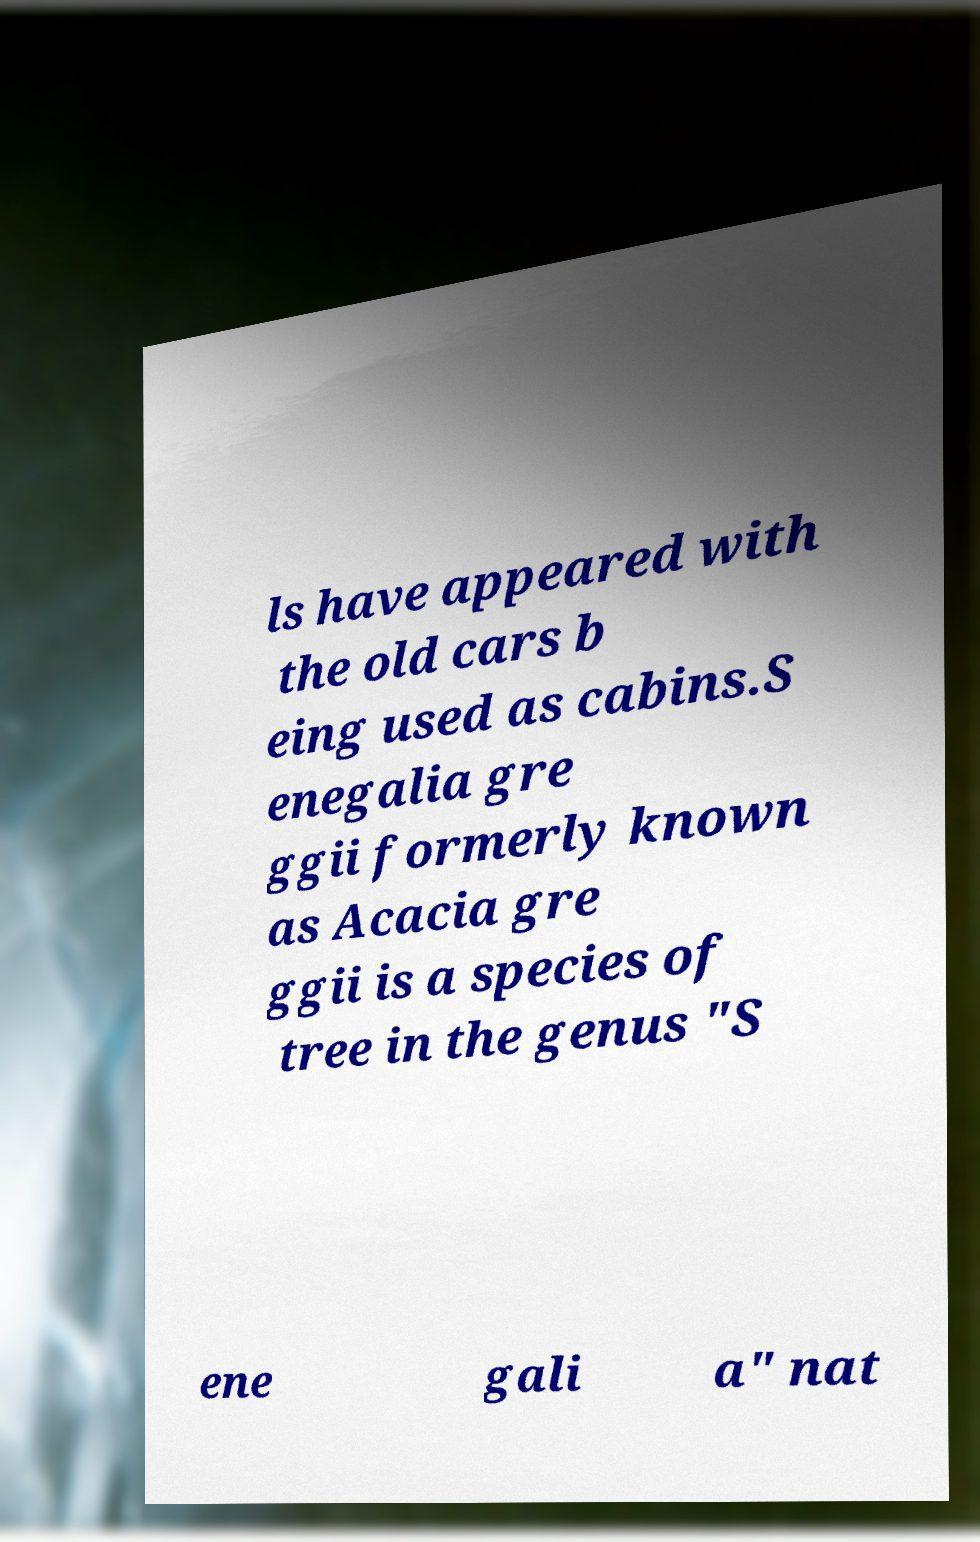What messages or text are displayed in this image? I need them in a readable, typed format. ls have appeared with the old cars b eing used as cabins.S enegalia gre ggii formerly known as Acacia gre ggii is a species of tree in the genus "S ene gali a" nat 